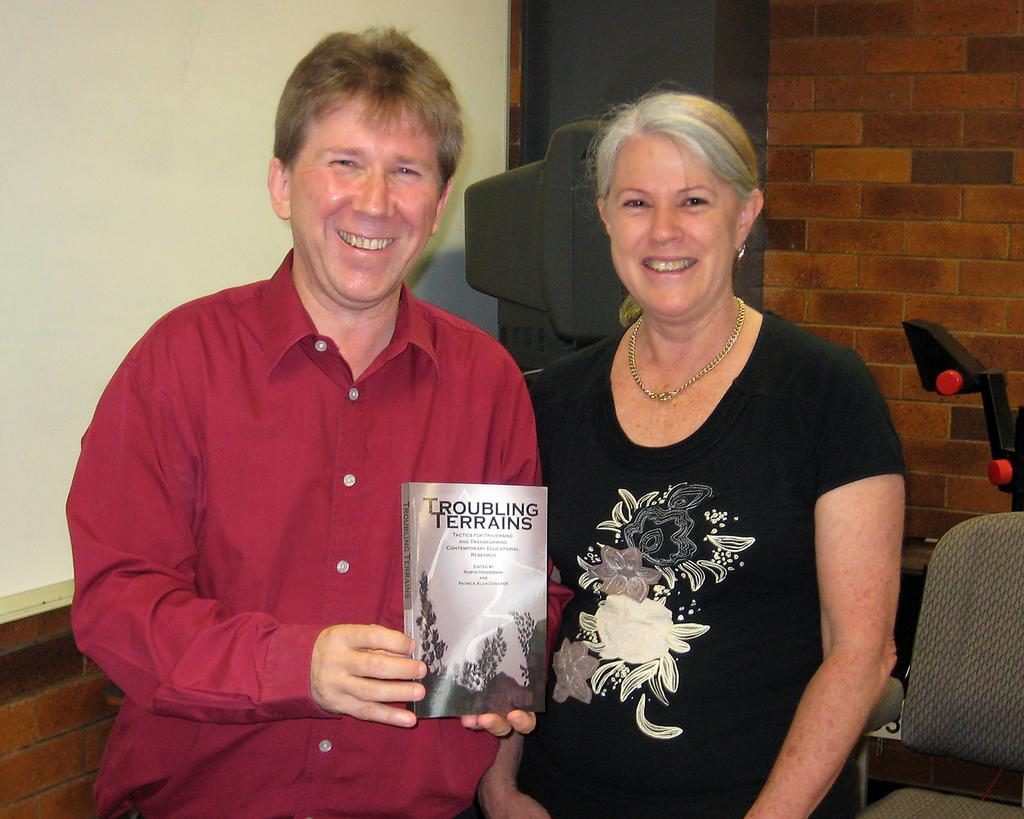Provide a one-sentence caption for the provided image. a man and a woman standing behind a book titled 'troubling terrains'. 